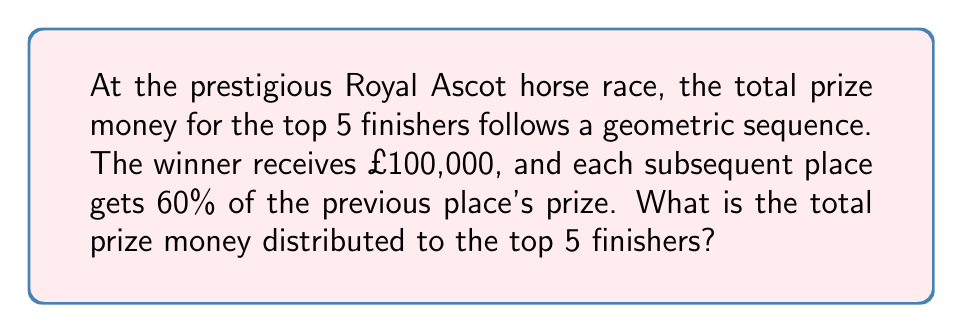Give your solution to this math problem. Let's approach this step-by-step:

1) We're dealing with a geometric sequence where the first term $a = £100,000$ and the common ratio $r = 0.6$ (60% of the previous prize).

2) The prize money for each place will be:
   1st place: $a_1 = £100,000$
   2nd place: $a_2 = £100,000 \times 0.6 = £60,000$
   3rd place: $a_3 = £60,000 \times 0.6 = £36,000$
   4th place: $a_4 = £36,000 \times 0.6 = £21,600$
   5th place: $a_5 = £21,600 \times 0.6 = £12,960$

3) To find the total, we need to sum these values. We can use the formula for the sum of a geometric series:

   $$S_n = \frac{a(1-r^n)}{1-r}$$

   Where $S_n$ is the sum, $a$ is the first term, $r$ is the common ratio, and $n$ is the number of terms.

4) Plugging in our values:
   $$S_5 = \frac{100,000(1-0.6^5)}{1-0.6}$$

5) Calculating:
   $$S_5 = \frac{100,000(1-0.07776)}{0.4} = \frac{100,000 \times 0.92224}{0.4} = 230,560$$

Therefore, the total prize money distributed to the top 5 finishers is £230,560.
Answer: £230,560 